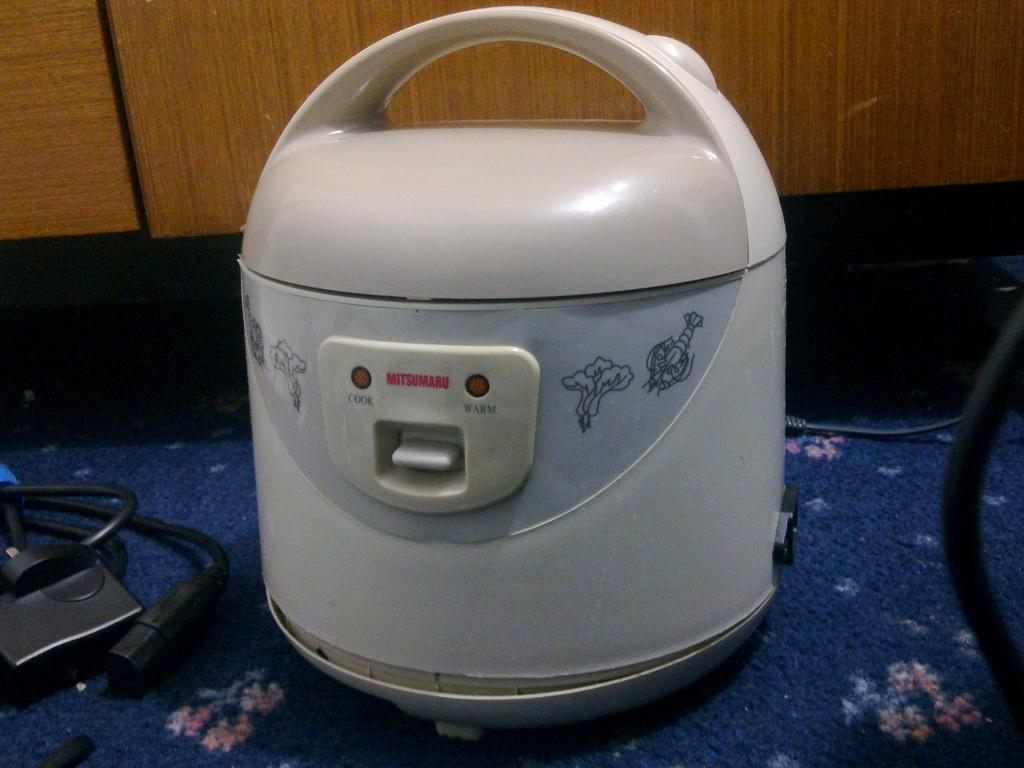What type of electronic device can be seen in the image? There is an electronic device in the image, but the specific type is not mentioned. What is connected to the electronic device in the image? Cable wires are visible in the image, which may be connected to the electronic device. What type of flooring is present in the image? There is a carpet in the image. What type of wall material is visible in the image? There is a wooden wall in the image. What type of gun is being used by the lawyer in the image? There is no lawyer or gun present in the image. 